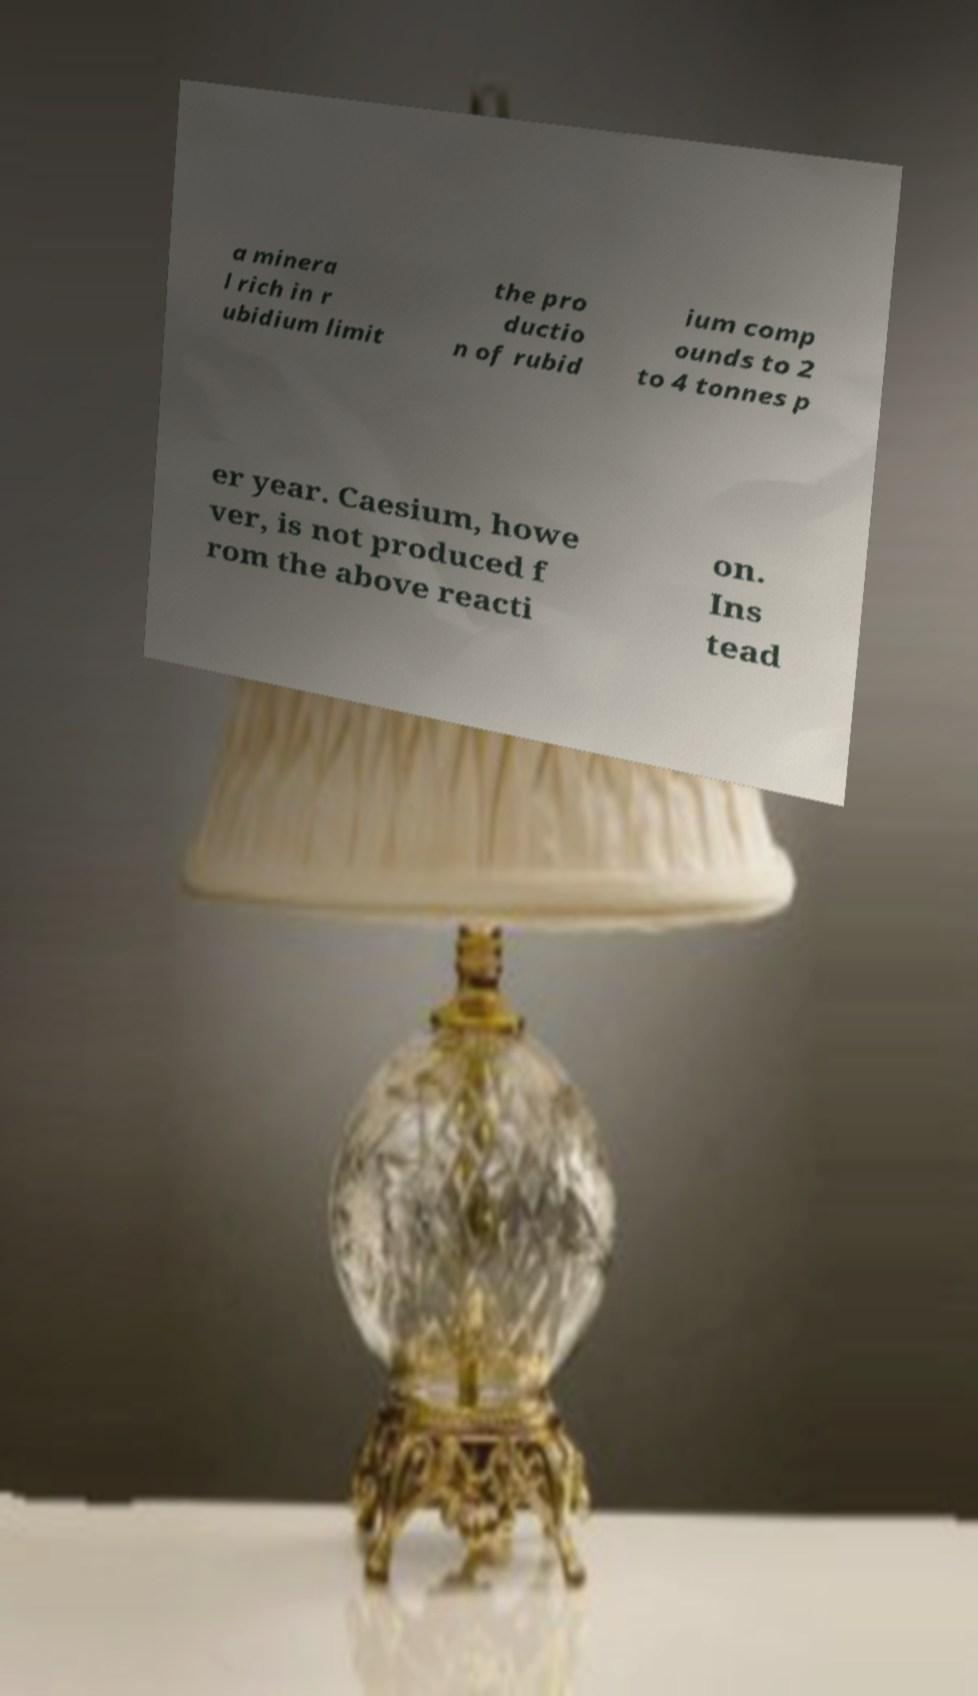Can you read and provide the text displayed in the image?This photo seems to have some interesting text. Can you extract and type it out for me? a minera l rich in r ubidium limit the pro ductio n of rubid ium comp ounds to 2 to 4 tonnes p er year. Caesium, howe ver, is not produced f rom the above reacti on. Ins tead 